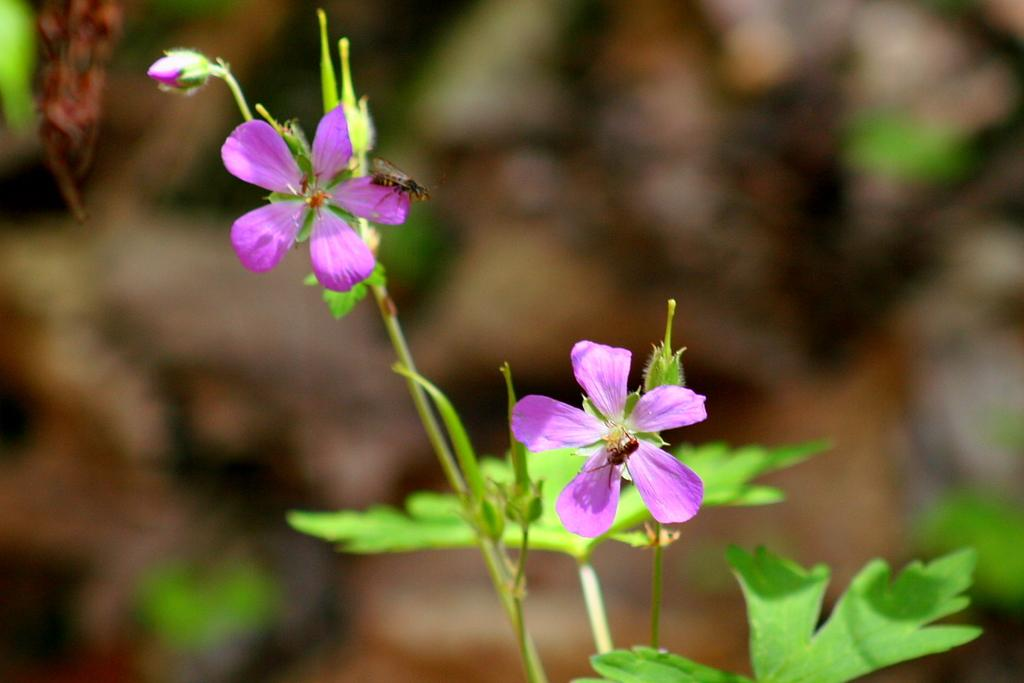What type of plants can be seen in the image? There are flowers in the image. What other parts of the plants are visible in the image? There are leaves and stems visible in the image. What other living organisms can be seen in the image? There are insects in the image. How would you describe the background of the image? The background of the image is blurred. What type of cake is being served in the image? There is no cake present in the image. What title is given to the insects in the image? There is no title given to the insects in the image; they are simply insects. 